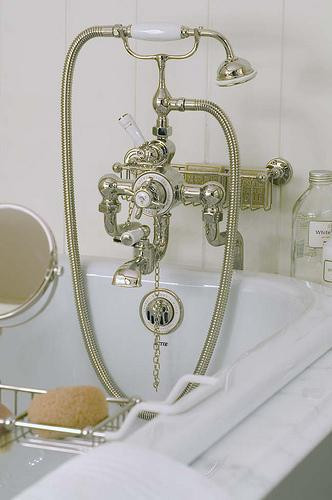As a multi-choice question, name an aspect of the image that could represent the quality of the product. Correct Answer: A) gold color tap In the context of a product advertisement, describe a possible use case for one of the items in the image. Experience a luxurious and refreshing bath time with our high-quality golden tap, designed with advanced water flow technology to help you relax and rejuvenate. Highlight some of the main items in the image. The image includes a golden color tap, a faucet, a mirror on the left side, a brown sponge in a metal tray, a white and blue symbol, and white handle of shower head. Describe one key feature related to the shower. The handle of the shower is white color and has a connected hose for the shower head. Identify a decorative detail in the image related to one of the bathroom features. The manufacturer logo on the bathtub is a decorative detail and has white and blue color. Mention three objects found in the bathroom scene and identify their colors. A golden tap, white and blue symbol, and a brown sponge are present in the bathroom scene. Identify an item in the image that could be used to clean yourself. A brown-colored sponge in a metal tray can be used for washing. 